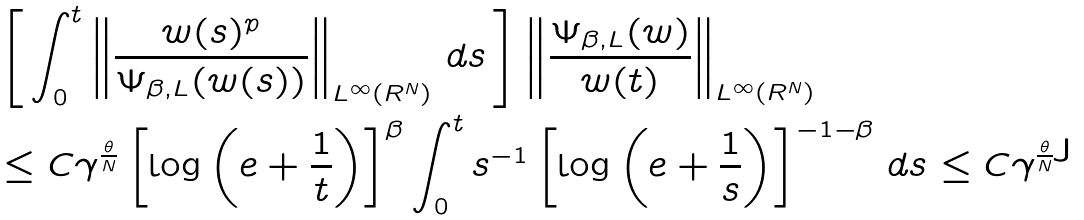Convert formula to latex. <formula><loc_0><loc_0><loc_500><loc_500>& \left [ \, \int _ { 0 } ^ { t } \left \| \frac { w ( s ) ^ { p } } { \Psi _ { \beta , L } ( w ( s ) ) } \right \| _ { L ^ { \infty } ( { R } ^ { N } ) } \, d s \, \right ] \left \| \frac { \Psi _ { \beta , L } ( w ) } { w ( t ) } \right \| _ { L ^ { \infty } ( { R } ^ { N } ) } \\ & \leq C \gamma ^ { \frac { \theta } { N } } \left [ \log \left ( e + \frac { 1 } { t } \right ) \right ] ^ { \beta } \int _ { 0 } ^ { t } s ^ { - 1 } \left [ \log \left ( e + \frac { 1 } { s } \right ) \right ] ^ { - 1 - \beta } \, d s \leq C \gamma ^ { \frac { \theta } { N } }</formula> 